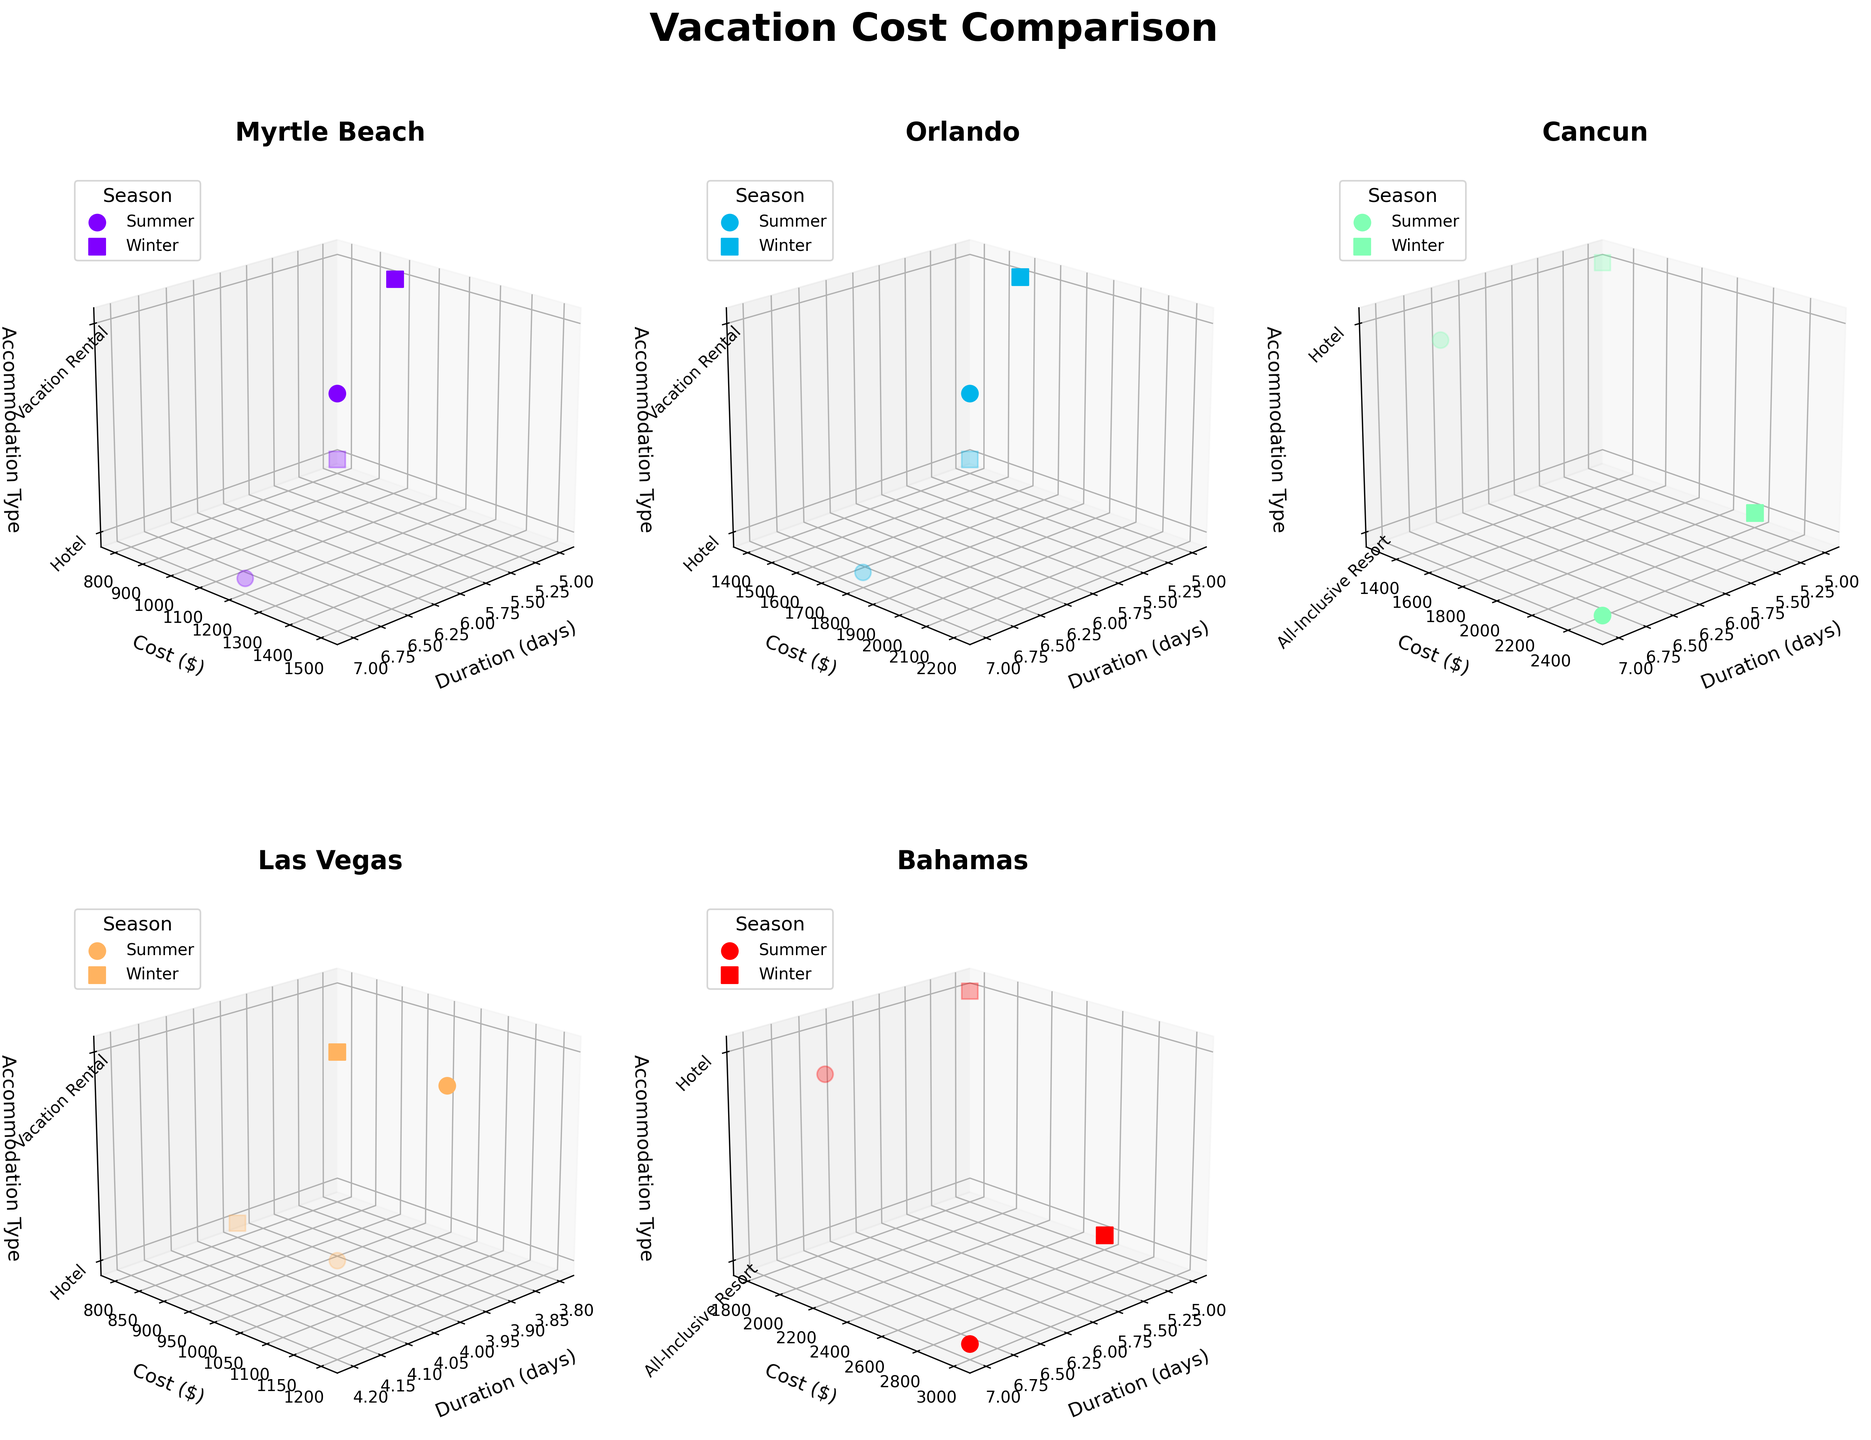How many subplots are in the figure? There are six destinations presented, and each destination is represented as a subplot in the figure.
Answer: 6 Which destination has the highest cost for a 7-day vacation in the summer? In the subplot for each destination, find the data point in Summer for a 7-day duration with the highest cost. The Bahamas show the highest cost at $3000 for a 7-day all-inclusive resort.
Answer: Bahamas Which season generally has higher vacation costs for Orlando? Compare the costs for each season (Summer and Winter) in the Orlando subplot. Summer shows generally higher vacation costs than Winter in Orlando.
Answer: Summer For Myrtle Beach, what is the cost difference between a 7-day hotel stay in the summer and a 5-day hotel stay in the winter? In the Myrtle Beach subplot, identify the 7-day hotel cost in Summer ($1200) and the 5-day hotel cost in Winter ($800). The difference is $1200 - $800 = $400.
Answer: $400 For a 7-day vacation rental, which destination has the lowest summer cost? Look across all subplots for the data points representing a 7-day vacation rental in Summer. Myrtle Beach shows the lowest cost of $1500.
Answer: Myrtle Beach How does the cost of hotel accommodation compare between Myrtle Beach and Las Vegas during winter? In the Myrtle Beach and Las Vegas subplots, compare the costs of hotel accommodation in Winter. Myrtle Beach costs $800 while Las Vegas costs $800, indicating they are equal.
Answer: Equal What accommodation type in Cancun costs the most in the summer and by how much does it surpass the next most expensive? In Cancun's subplot, summer’s costs for each accommodation type show the All-Inclusive Resort at $2500 and Hotel at $1600. The difference is $2500 - $1600 = $900.
Answer: All-Inclusive Resort, $900 Arrange the destinations in descending order based on the highest cost of winter accommodation. Identify the highest winter cost in each destination and sort them: Bahamas ($2600), Cancun ($2200), Orlando ($1600), Myrtle Beach ($1000), Las Vegas ($1000).
Answer: Bahamas, Cancun, Orlando, Myrtle Beach, Las Vegas Which has a higher cost in the summer at Cancun, a 7-day Hotel stay or a 5-day All-Inclusive Resort stay? In the Cancun subplot, compare the summer cost of a 7-day Hotel stay ($1600) with a 5-day All-Inclusive Resort stay ($2200). The 5-day All-Inclusive Resort stay is higher.
Answer: 5-day All-Inclusive Resort In how many destinations do Vacation Rentals generally cost more in Winter compared to Summer? Compare the costs of Vacation Rentals in Winter and Summer for each destination: Myrtle Beach (Winter<), Orlando (Winter<), Las Vegas (Winter==), hence 0 destinations generally have higher winter costs compared to summer for Vacation Rentals.
Answer: 0 